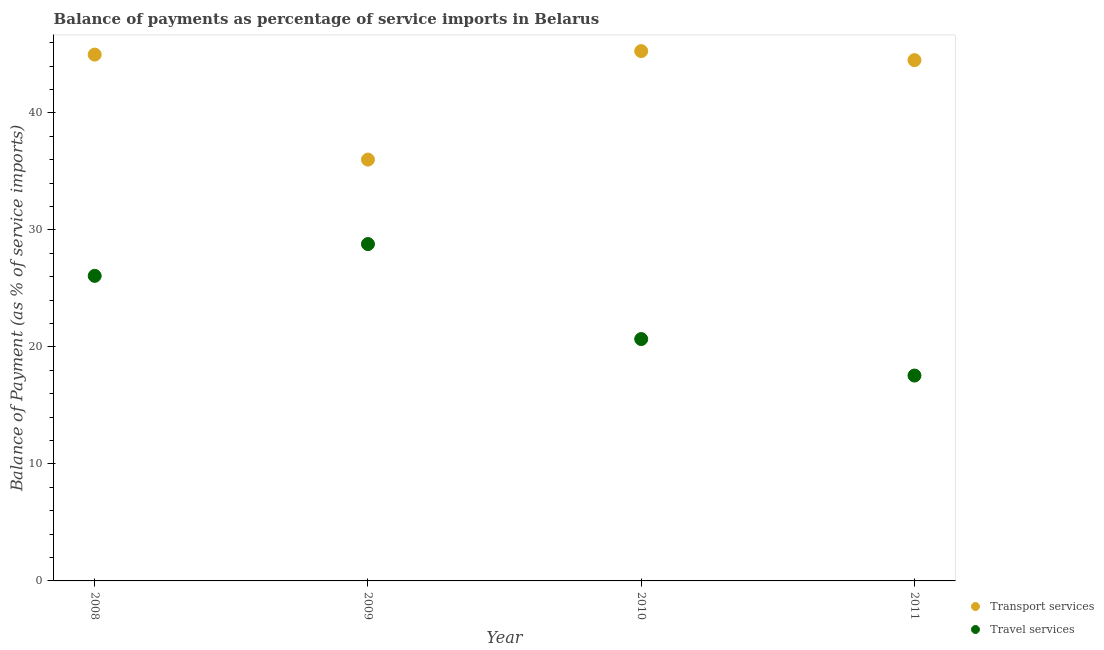Is the number of dotlines equal to the number of legend labels?
Your answer should be compact. Yes. What is the balance of payments of transport services in 2011?
Provide a succinct answer. 44.51. Across all years, what is the maximum balance of payments of transport services?
Keep it short and to the point. 45.28. Across all years, what is the minimum balance of payments of transport services?
Make the answer very short. 36.01. In which year was the balance of payments of transport services maximum?
Your answer should be compact. 2010. What is the total balance of payments of travel services in the graph?
Your response must be concise. 93.08. What is the difference between the balance of payments of transport services in 2009 and that in 2010?
Offer a terse response. -9.27. What is the difference between the balance of payments of travel services in 2011 and the balance of payments of transport services in 2009?
Provide a short and direct response. -18.46. What is the average balance of payments of transport services per year?
Provide a short and direct response. 42.69. In the year 2009, what is the difference between the balance of payments of transport services and balance of payments of travel services?
Ensure brevity in your answer.  7.22. In how many years, is the balance of payments of travel services greater than 36 %?
Your answer should be very brief. 0. What is the ratio of the balance of payments of transport services in 2008 to that in 2011?
Make the answer very short. 1.01. Is the balance of payments of travel services in 2009 less than that in 2010?
Ensure brevity in your answer.  No. Is the difference between the balance of payments of travel services in 2008 and 2011 greater than the difference between the balance of payments of transport services in 2008 and 2011?
Provide a short and direct response. Yes. What is the difference between the highest and the second highest balance of payments of travel services?
Your response must be concise. 2.72. What is the difference between the highest and the lowest balance of payments of transport services?
Make the answer very short. 9.27. Is the sum of the balance of payments of travel services in 2008 and 2009 greater than the maximum balance of payments of transport services across all years?
Your answer should be very brief. Yes. How many years are there in the graph?
Make the answer very short. 4. Are the values on the major ticks of Y-axis written in scientific E-notation?
Provide a short and direct response. No. Does the graph contain grids?
Keep it short and to the point. No. Where does the legend appear in the graph?
Give a very brief answer. Bottom right. How many legend labels are there?
Your answer should be compact. 2. What is the title of the graph?
Your response must be concise. Balance of payments as percentage of service imports in Belarus. What is the label or title of the X-axis?
Keep it short and to the point. Year. What is the label or title of the Y-axis?
Keep it short and to the point. Balance of Payment (as % of service imports). What is the Balance of Payment (as % of service imports) in Transport services in 2008?
Make the answer very short. 44.98. What is the Balance of Payment (as % of service imports) in Travel services in 2008?
Provide a succinct answer. 26.07. What is the Balance of Payment (as % of service imports) in Transport services in 2009?
Provide a succinct answer. 36.01. What is the Balance of Payment (as % of service imports) of Travel services in 2009?
Make the answer very short. 28.79. What is the Balance of Payment (as % of service imports) in Transport services in 2010?
Your response must be concise. 45.28. What is the Balance of Payment (as % of service imports) of Travel services in 2010?
Offer a terse response. 20.67. What is the Balance of Payment (as % of service imports) of Transport services in 2011?
Your response must be concise. 44.51. What is the Balance of Payment (as % of service imports) of Travel services in 2011?
Your answer should be very brief. 17.55. Across all years, what is the maximum Balance of Payment (as % of service imports) in Transport services?
Give a very brief answer. 45.28. Across all years, what is the maximum Balance of Payment (as % of service imports) of Travel services?
Give a very brief answer. 28.79. Across all years, what is the minimum Balance of Payment (as % of service imports) of Transport services?
Provide a short and direct response. 36.01. Across all years, what is the minimum Balance of Payment (as % of service imports) of Travel services?
Provide a short and direct response. 17.55. What is the total Balance of Payment (as % of service imports) of Transport services in the graph?
Your answer should be compact. 170.77. What is the total Balance of Payment (as % of service imports) in Travel services in the graph?
Your response must be concise. 93.08. What is the difference between the Balance of Payment (as % of service imports) in Transport services in 2008 and that in 2009?
Provide a short and direct response. 8.97. What is the difference between the Balance of Payment (as % of service imports) of Travel services in 2008 and that in 2009?
Give a very brief answer. -2.72. What is the difference between the Balance of Payment (as % of service imports) of Transport services in 2008 and that in 2010?
Offer a terse response. -0.3. What is the difference between the Balance of Payment (as % of service imports) of Travel services in 2008 and that in 2010?
Make the answer very short. 5.4. What is the difference between the Balance of Payment (as % of service imports) of Transport services in 2008 and that in 2011?
Your answer should be compact. 0.47. What is the difference between the Balance of Payment (as % of service imports) of Travel services in 2008 and that in 2011?
Keep it short and to the point. 8.52. What is the difference between the Balance of Payment (as % of service imports) in Transport services in 2009 and that in 2010?
Your answer should be very brief. -9.27. What is the difference between the Balance of Payment (as % of service imports) of Travel services in 2009 and that in 2010?
Your answer should be compact. 8.12. What is the difference between the Balance of Payment (as % of service imports) in Transport services in 2009 and that in 2011?
Offer a terse response. -8.5. What is the difference between the Balance of Payment (as % of service imports) of Travel services in 2009 and that in 2011?
Provide a succinct answer. 11.24. What is the difference between the Balance of Payment (as % of service imports) in Transport services in 2010 and that in 2011?
Ensure brevity in your answer.  0.77. What is the difference between the Balance of Payment (as % of service imports) of Travel services in 2010 and that in 2011?
Offer a terse response. 3.12. What is the difference between the Balance of Payment (as % of service imports) in Transport services in 2008 and the Balance of Payment (as % of service imports) in Travel services in 2009?
Keep it short and to the point. 16.19. What is the difference between the Balance of Payment (as % of service imports) of Transport services in 2008 and the Balance of Payment (as % of service imports) of Travel services in 2010?
Offer a very short reply. 24.31. What is the difference between the Balance of Payment (as % of service imports) of Transport services in 2008 and the Balance of Payment (as % of service imports) of Travel services in 2011?
Provide a short and direct response. 27.43. What is the difference between the Balance of Payment (as % of service imports) of Transport services in 2009 and the Balance of Payment (as % of service imports) of Travel services in 2010?
Ensure brevity in your answer.  15.34. What is the difference between the Balance of Payment (as % of service imports) of Transport services in 2009 and the Balance of Payment (as % of service imports) of Travel services in 2011?
Keep it short and to the point. 18.46. What is the difference between the Balance of Payment (as % of service imports) in Transport services in 2010 and the Balance of Payment (as % of service imports) in Travel services in 2011?
Offer a very short reply. 27.73. What is the average Balance of Payment (as % of service imports) of Transport services per year?
Your response must be concise. 42.69. What is the average Balance of Payment (as % of service imports) in Travel services per year?
Provide a succinct answer. 23.27. In the year 2008, what is the difference between the Balance of Payment (as % of service imports) of Transport services and Balance of Payment (as % of service imports) of Travel services?
Provide a short and direct response. 18.91. In the year 2009, what is the difference between the Balance of Payment (as % of service imports) in Transport services and Balance of Payment (as % of service imports) in Travel services?
Your answer should be compact. 7.22. In the year 2010, what is the difference between the Balance of Payment (as % of service imports) in Transport services and Balance of Payment (as % of service imports) in Travel services?
Provide a short and direct response. 24.61. In the year 2011, what is the difference between the Balance of Payment (as % of service imports) in Transport services and Balance of Payment (as % of service imports) in Travel services?
Give a very brief answer. 26.96. What is the ratio of the Balance of Payment (as % of service imports) of Transport services in 2008 to that in 2009?
Keep it short and to the point. 1.25. What is the ratio of the Balance of Payment (as % of service imports) in Travel services in 2008 to that in 2009?
Your response must be concise. 0.91. What is the ratio of the Balance of Payment (as % of service imports) of Transport services in 2008 to that in 2010?
Your response must be concise. 0.99. What is the ratio of the Balance of Payment (as % of service imports) of Travel services in 2008 to that in 2010?
Provide a succinct answer. 1.26. What is the ratio of the Balance of Payment (as % of service imports) in Transport services in 2008 to that in 2011?
Keep it short and to the point. 1.01. What is the ratio of the Balance of Payment (as % of service imports) of Travel services in 2008 to that in 2011?
Offer a very short reply. 1.49. What is the ratio of the Balance of Payment (as % of service imports) of Transport services in 2009 to that in 2010?
Give a very brief answer. 0.8. What is the ratio of the Balance of Payment (as % of service imports) in Travel services in 2009 to that in 2010?
Provide a succinct answer. 1.39. What is the ratio of the Balance of Payment (as % of service imports) of Transport services in 2009 to that in 2011?
Make the answer very short. 0.81. What is the ratio of the Balance of Payment (as % of service imports) of Travel services in 2009 to that in 2011?
Provide a short and direct response. 1.64. What is the ratio of the Balance of Payment (as % of service imports) in Transport services in 2010 to that in 2011?
Your answer should be very brief. 1.02. What is the ratio of the Balance of Payment (as % of service imports) of Travel services in 2010 to that in 2011?
Ensure brevity in your answer.  1.18. What is the difference between the highest and the second highest Balance of Payment (as % of service imports) of Transport services?
Give a very brief answer. 0.3. What is the difference between the highest and the second highest Balance of Payment (as % of service imports) of Travel services?
Give a very brief answer. 2.72. What is the difference between the highest and the lowest Balance of Payment (as % of service imports) of Transport services?
Ensure brevity in your answer.  9.27. What is the difference between the highest and the lowest Balance of Payment (as % of service imports) in Travel services?
Your answer should be compact. 11.24. 